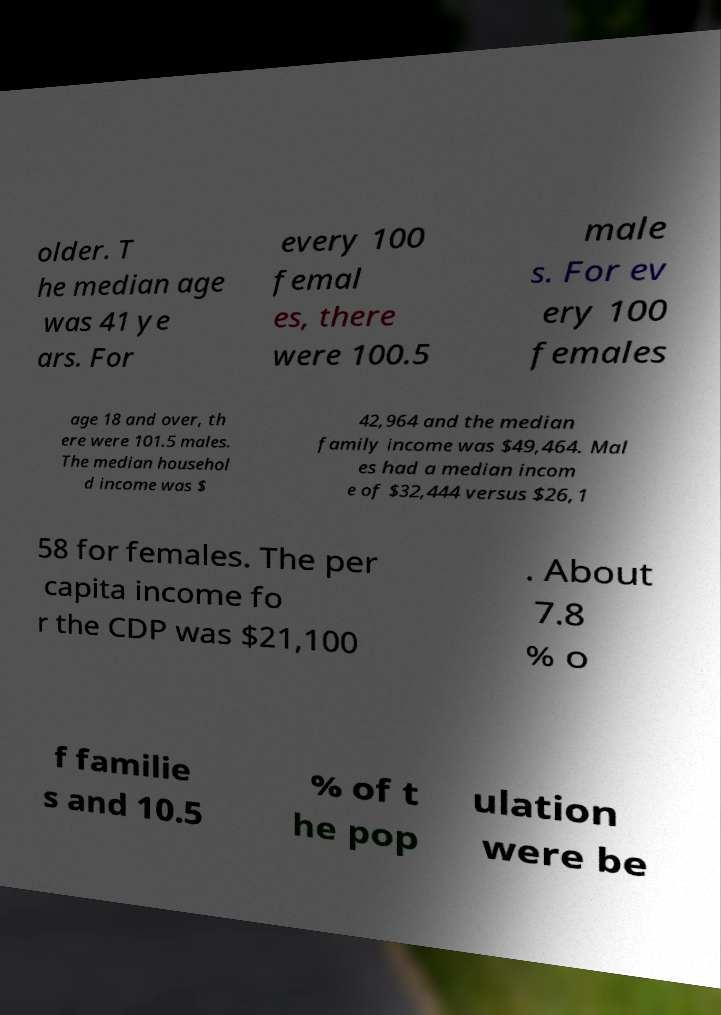Please read and relay the text visible in this image. What does it say? older. T he median age was 41 ye ars. For every 100 femal es, there were 100.5 male s. For ev ery 100 females age 18 and over, th ere were 101.5 males. The median househol d income was $ 42,964 and the median family income was $49,464. Mal es had a median incom e of $32,444 versus $26,1 58 for females. The per capita income fo r the CDP was $21,100 . About 7.8 % o f familie s and 10.5 % of t he pop ulation were be 